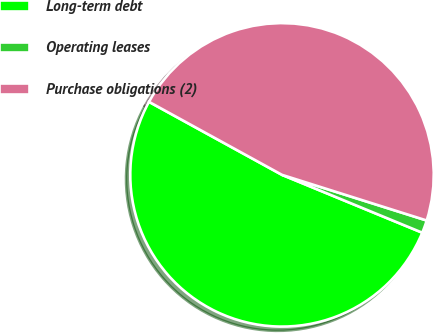<chart> <loc_0><loc_0><loc_500><loc_500><pie_chart><fcel>Long-term debt<fcel>Operating leases<fcel>Purchase obligations (2)<nl><fcel>51.77%<fcel>1.36%<fcel>46.88%<nl></chart> 